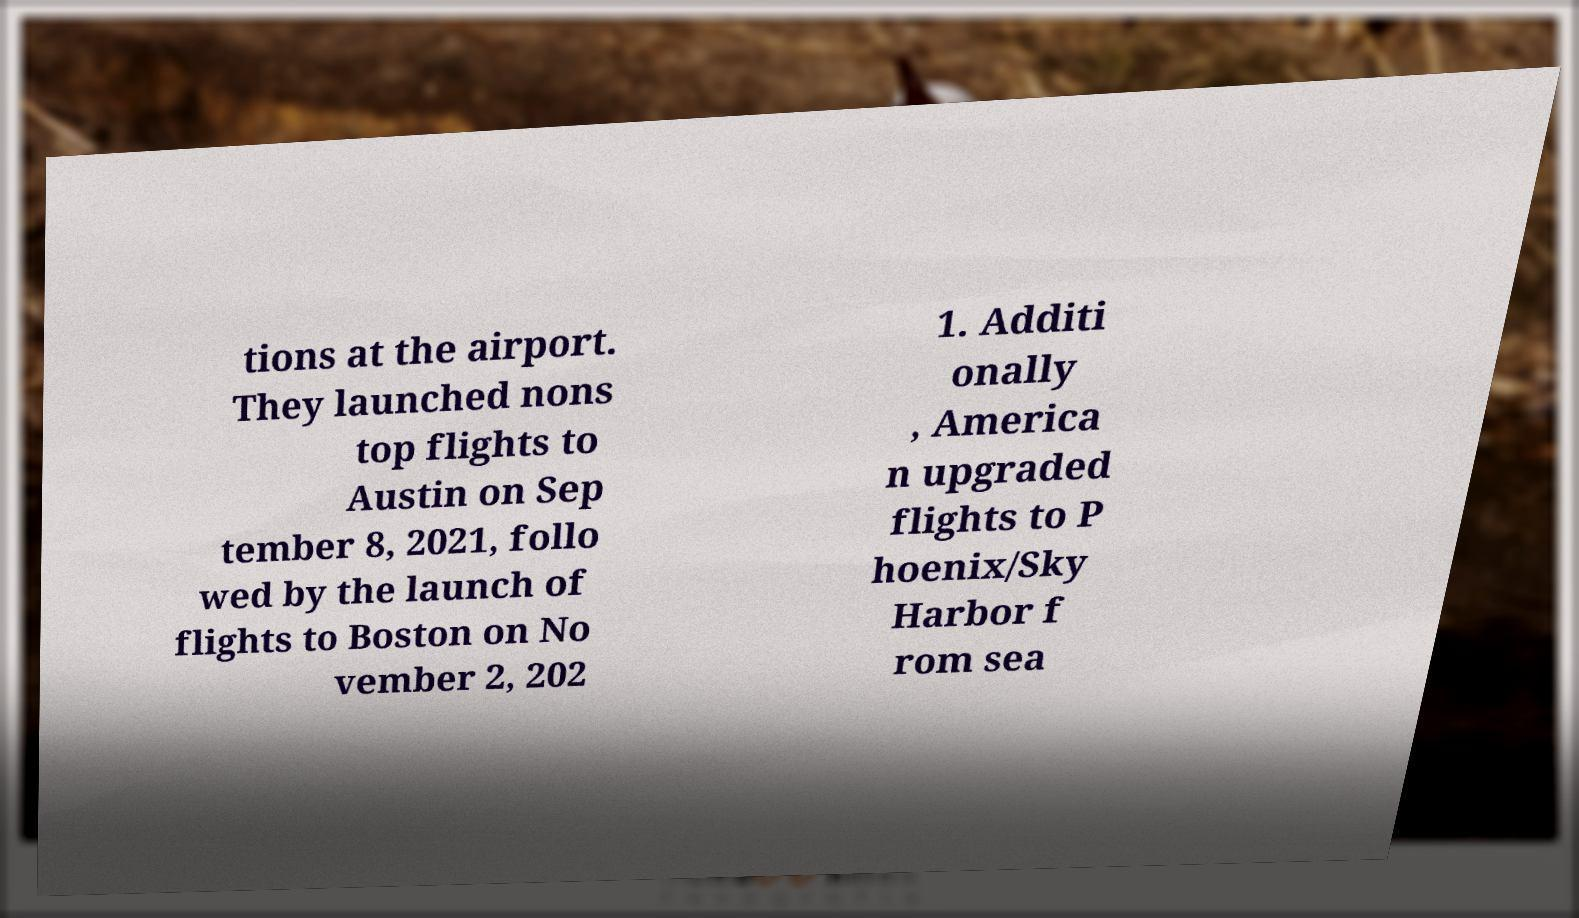For documentation purposes, I need the text within this image transcribed. Could you provide that? tions at the airport. They launched nons top flights to Austin on Sep tember 8, 2021, follo wed by the launch of flights to Boston on No vember 2, 202 1. Additi onally , America n upgraded flights to P hoenix/Sky Harbor f rom sea 